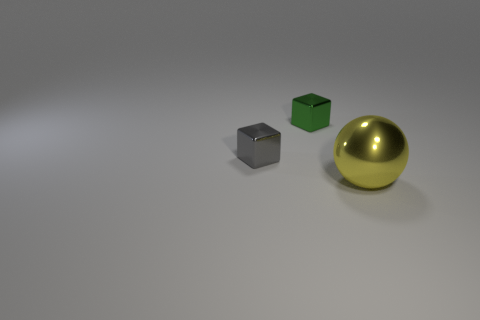Is there a gray metallic thing that has the same size as the yellow thing?
Your answer should be compact. No. There is a tiny metal object to the right of the tiny block on the left side of the green metal object; what color is it?
Provide a short and direct response. Green. What number of small gray cubes are there?
Provide a succinct answer. 1. Are there fewer green shiny blocks that are in front of the large yellow metal sphere than tiny gray metallic objects left of the gray metallic object?
Offer a terse response. No. What color is the big metallic ball?
Keep it short and to the point. Yellow. There is a big yellow metal object; are there any gray objects to the right of it?
Offer a very short reply. No. Is the number of large yellow objects that are on the right side of the yellow metallic ball the same as the number of big objects behind the small gray block?
Give a very brief answer. Yes. There is a metal block in front of the tiny green shiny block; is it the same size as the yellow ball that is to the right of the gray thing?
Keep it short and to the point. No. The thing that is behind the cube on the left side of the tiny object on the right side of the small gray shiny object is what shape?
Keep it short and to the point. Cube. Is there any other thing that has the same material as the green thing?
Your answer should be compact. Yes. 